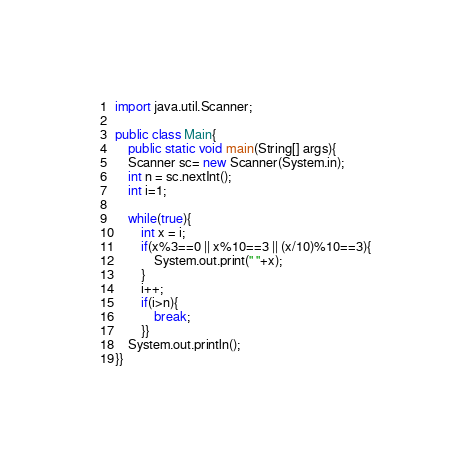Convert code to text. <code><loc_0><loc_0><loc_500><loc_500><_Java_>import java.util.Scanner;

public class Main{
    public static void main(String[] args){
	Scanner sc= new Scanner(System.in);
	int n = sc.nextInt();
	int i=1;
	
	while(true){
		int x = i;
		if(x%3==0 || x%10==3 || (x/10)%10==3){
			System.out.print(" "+x);
		}
		i++;
		if(i>n){
			break;
		}}	
	System.out.println();
}}</code> 